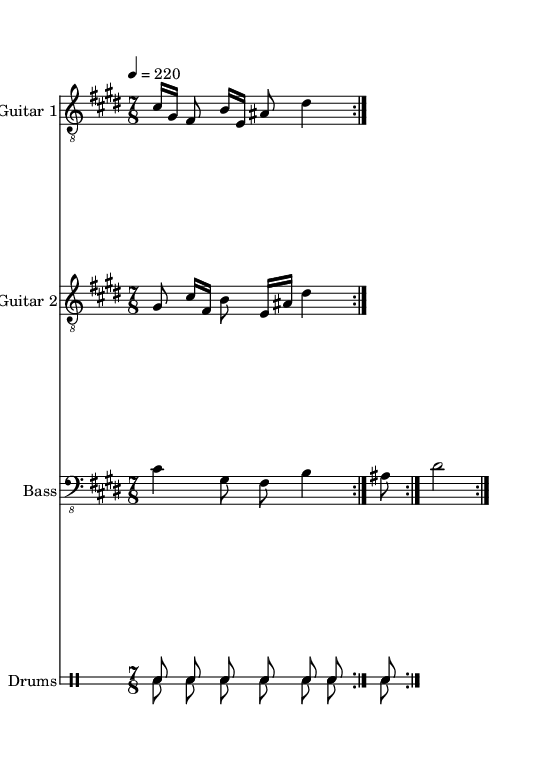What is the key signature of this music? The key signature shows a single sharp when looking at the left-hand side of the staff. Specifically, it is C# minor, which is indicated by the notes, as the phrases revolve around C#, and generally has four sharps in their scale.
Answer: C# minor What is the time signature of the piece? The time signature is displayed right after the clef symbol at the beginning of the staff. It reads 7/8, indicating that there are seven beats in each measure and an eighth note gets one beat.
Answer: 7/8 What is the tempo marking? The tempo marking is provided in beats per minute and positioned early in the score, as it says "4 = 220," which means to play the quarter notes at a speed of 220 beats per minute.
Answer: 220 How many bars are in each repeat? By inspecting the repeated sections within the music, each section contains two bars before repeating, as shown by the repeat volta marking which appears after those bars.
Answer: 2 What is the style of this metal composition? The characteristics of the score reflect the genre through the complex time signatures, the use of riffs, and intricate drumming patterns typical to technical death metal. The indication of clear rhythm differences between the two guitars signifies its complexity.
Answer: Technical death metal Which instrument plays the main melodic lines? Analyzing the score, it becomes apparent that Guitar 1 primarily plays the main melodic content, denoted by its placement in the score with treble notes and more complex rhythms compared to the other instruments.
Answer: Guitar 1 